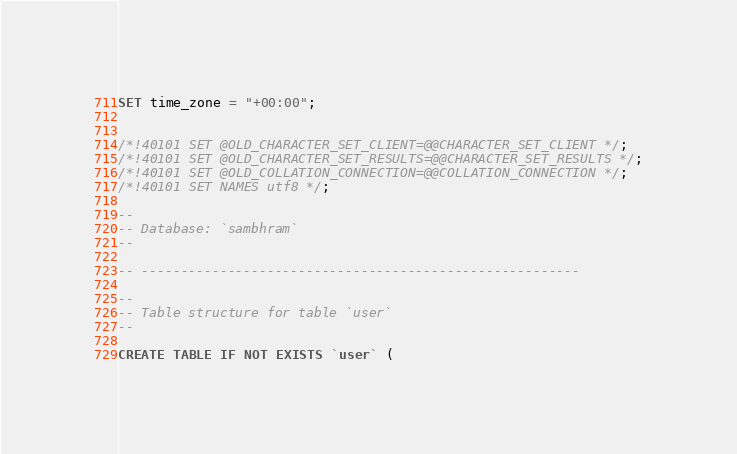Convert code to text. <code><loc_0><loc_0><loc_500><loc_500><_SQL_>SET time_zone = "+00:00";


/*!40101 SET @OLD_CHARACTER_SET_CLIENT=@@CHARACTER_SET_CLIENT */;
/*!40101 SET @OLD_CHARACTER_SET_RESULTS=@@CHARACTER_SET_RESULTS */;
/*!40101 SET @OLD_COLLATION_CONNECTION=@@COLLATION_CONNECTION */;
/*!40101 SET NAMES utf8 */;

--
-- Database: `sambhram`
--

-- --------------------------------------------------------

--
-- Table structure for table `user`
--

CREATE TABLE IF NOT EXISTS `user` (</code> 